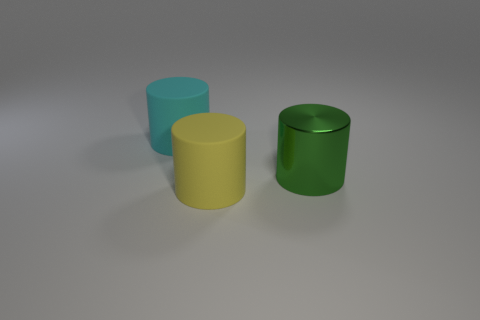Subtract 1 cylinders. How many cylinders are left? 2 Add 1 yellow rubber cylinders. How many objects exist? 4 Subtract 0 blue cubes. How many objects are left? 3 Subtract all small red matte blocks. Subtract all large yellow matte things. How many objects are left? 2 Add 2 cyan things. How many cyan things are left? 3 Add 1 green things. How many green things exist? 2 